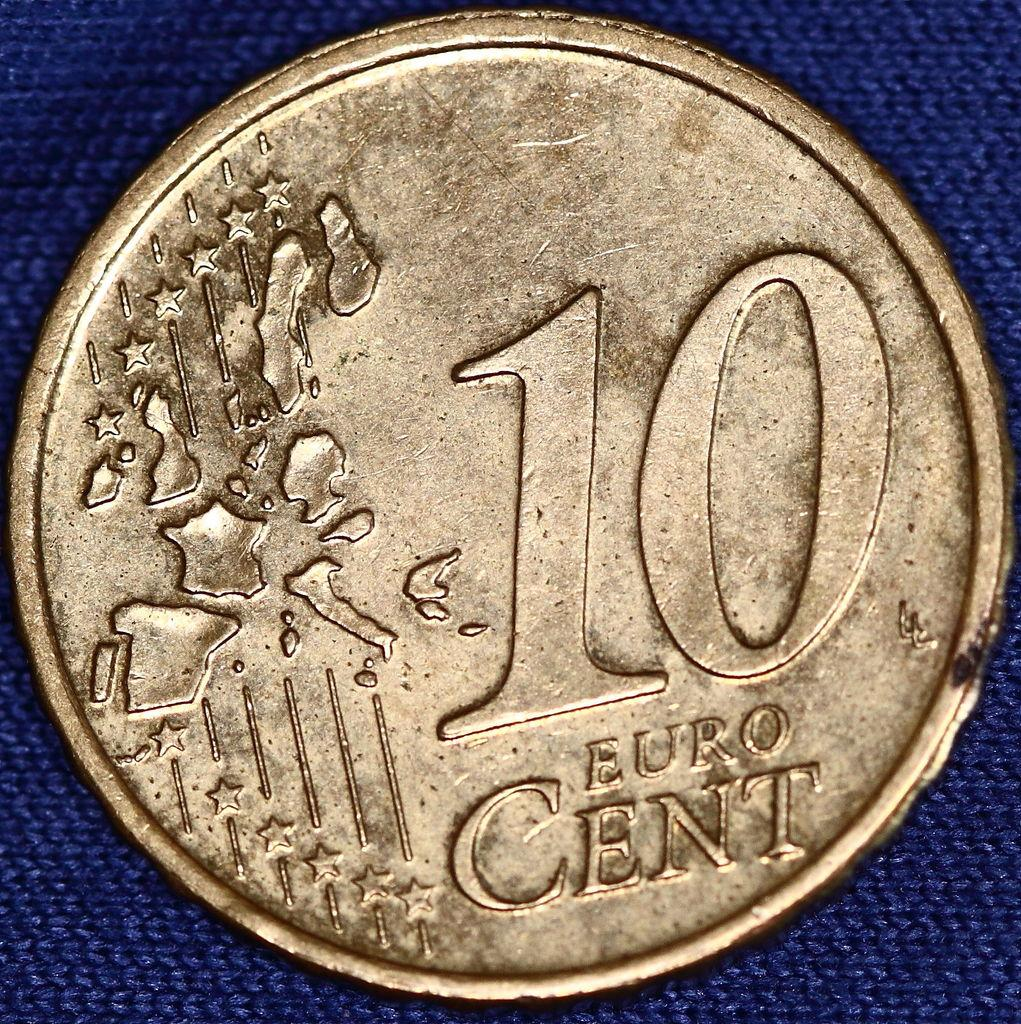<image>
Offer a succinct explanation of the picture presented. A gold 10 Euro cent coin with stars and images of european countries on it 